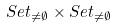<formula> <loc_0><loc_0><loc_500><loc_500>S e t _ { \ne \emptyset } \times S e t _ { \ne \emptyset }</formula> 